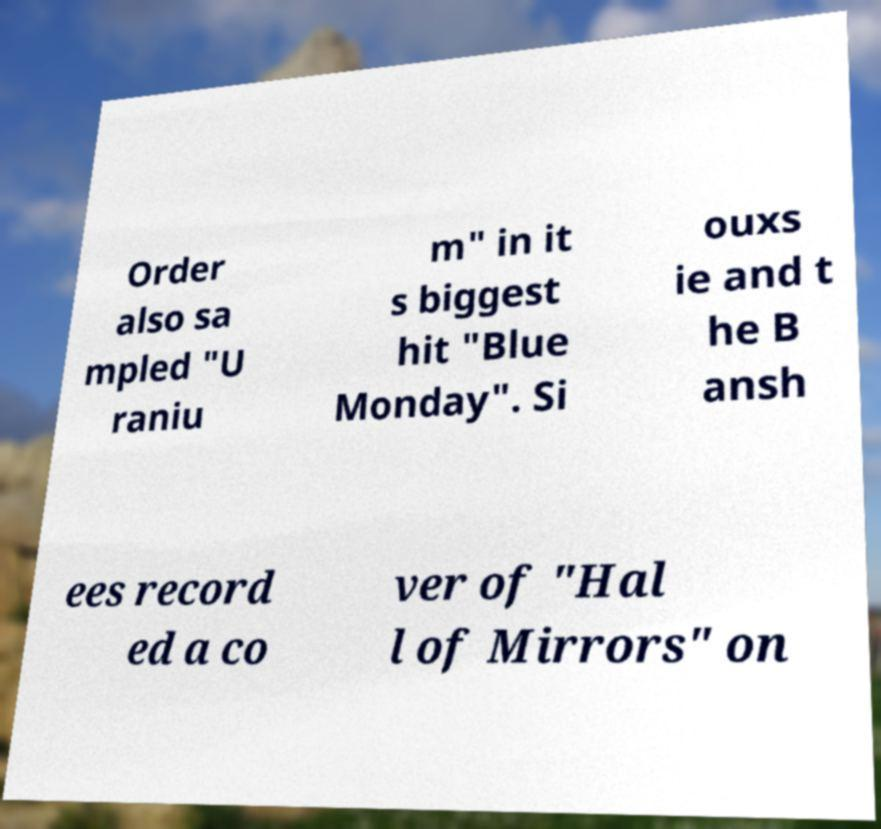Please read and relay the text visible in this image. What does it say? Order also sa mpled "U raniu m" in it s biggest hit "Blue Monday". Si ouxs ie and t he B ansh ees record ed a co ver of "Hal l of Mirrors" on 